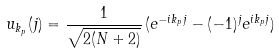<formula> <loc_0><loc_0><loc_500><loc_500>u _ { k _ { p } } ( j ) = \frac { 1 } { \sqrt { 2 ( N + 2 ) } } \, ( e ^ { - i k _ { p } j } - ( - 1 ) ^ { j } e ^ { i k _ { p } j } )</formula> 